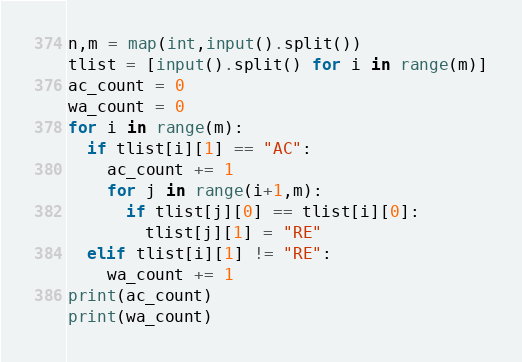Convert code to text. <code><loc_0><loc_0><loc_500><loc_500><_Python_>n,m = map(int,input().split())
tlist = [input().split() for i in range(m)]
ac_count = 0
wa_count = 0
for i in range(m):
  if tlist[i][1] == "AC":
    ac_count += 1
    for j in range(i+1,m):
      if tlist[j][0] == tlist[i][0]:
        tlist[j][1] = "RE"
  elif tlist[i][1] != "RE":
    wa_count += 1
print(ac_count)
print(wa_count)</code> 